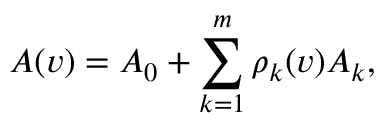<formula> <loc_0><loc_0><loc_500><loc_500>A ( v ) = A _ { 0 } + \sum _ { k = 1 } ^ { m } \rho _ { k } ( v ) A _ { k } ,</formula> 